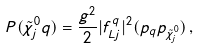Convert formula to latex. <formula><loc_0><loc_0><loc_500><loc_500>P ( \tilde { \chi } ^ { 0 } _ { j } q ) = \frac { g ^ { 2 } } { 2 } | f _ { L j } ^ { q } | ^ { 2 } ( p _ { q } p _ { \tilde { \chi } ^ { 0 } _ { j } } ) \, ,</formula> 